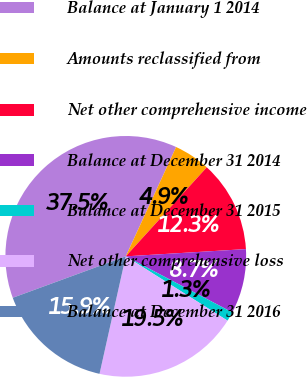Convert chart to OTSL. <chart><loc_0><loc_0><loc_500><loc_500><pie_chart><fcel>Balance at January 1 2014<fcel>Amounts reclassified from<fcel>Net other comprehensive income<fcel>Balance at December 31 2014<fcel>Balance at December 31 2015<fcel>Net other comprehensive loss<fcel>Balance at December 31 2016<nl><fcel>37.46%<fcel>4.88%<fcel>12.29%<fcel>8.67%<fcel>1.26%<fcel>19.53%<fcel>15.91%<nl></chart> 